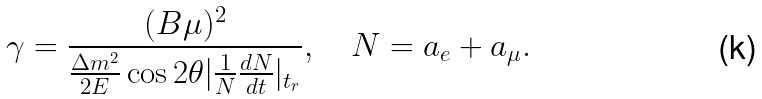Convert formula to latex. <formula><loc_0><loc_0><loc_500><loc_500>\gamma = { \frac { ( B \mu ) ^ { 2 } } { { \frac { \Delta m ^ { 2 } } { 2 E } } \cos 2 \theta | { \frac { 1 } { N } } { \frac { d N } { d t } } | _ { t _ { r } } } } , \quad N = a _ { e } + a _ { \mu } .</formula> 